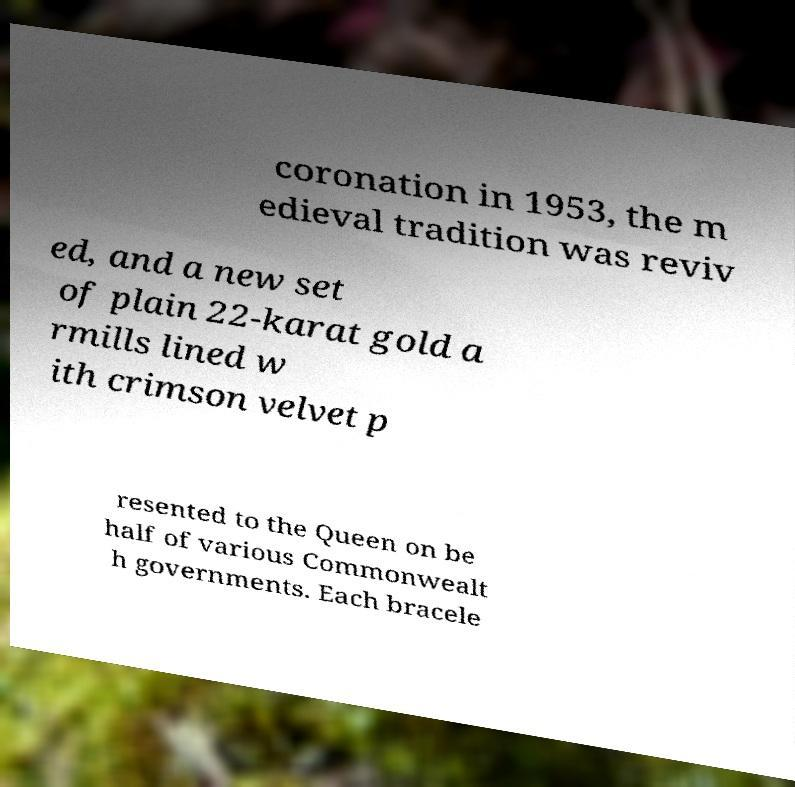What messages or text are displayed in this image? I need them in a readable, typed format. coronation in 1953, the m edieval tradition was reviv ed, and a new set of plain 22-karat gold a rmills lined w ith crimson velvet p resented to the Queen on be half of various Commonwealt h governments. Each bracele 